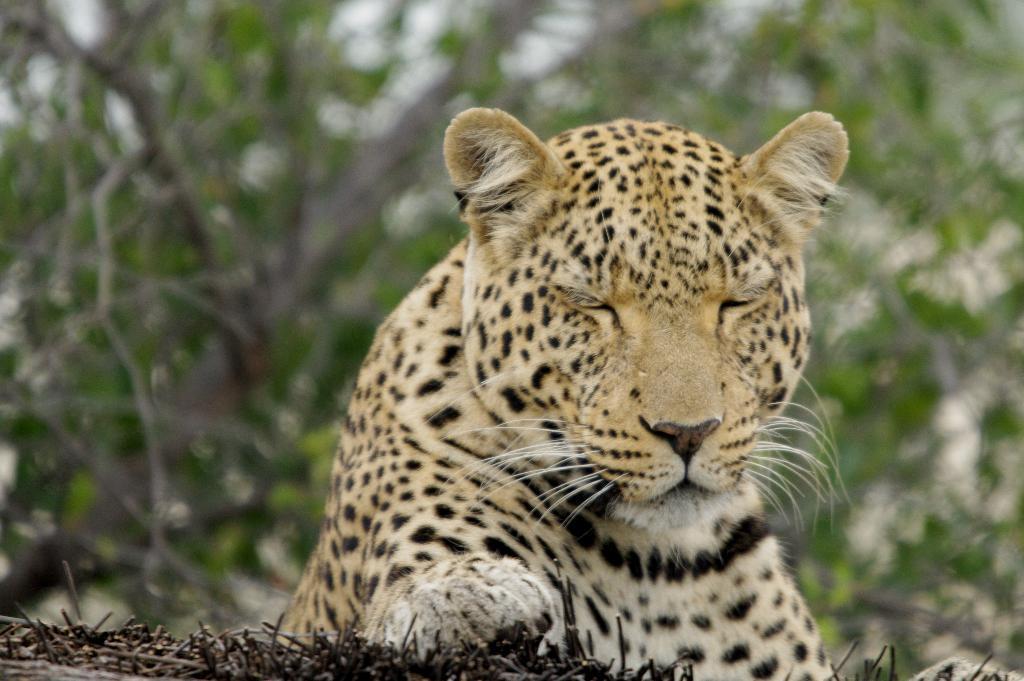Can you describe this image briefly? In the middle of this image, there is a tiger in yellow and black color combination on a ground. In the background, there are trees. And the background is blurred. 